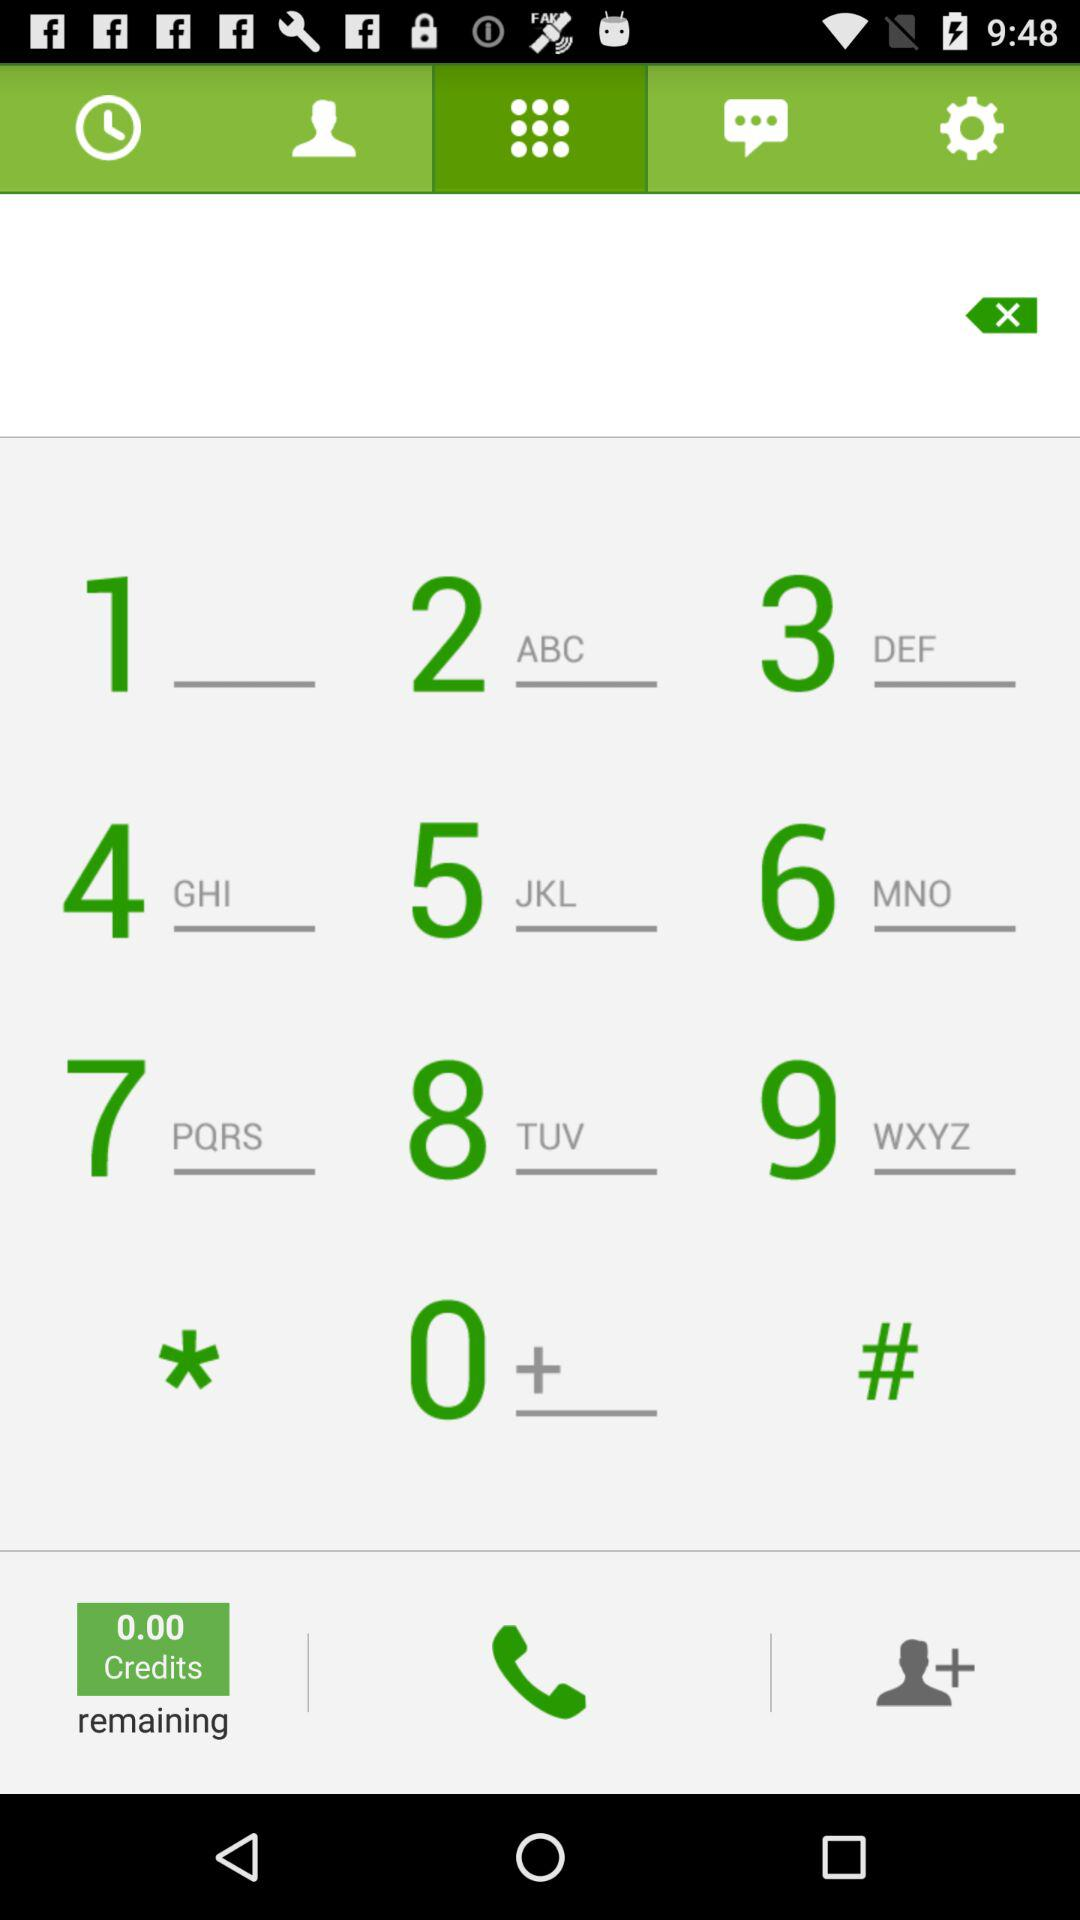How many credits are remaining? There are 0 credits remaining. 